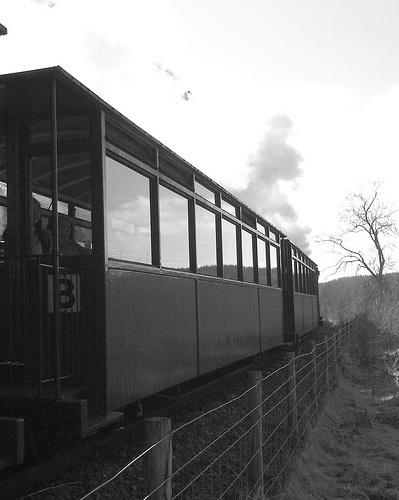What is the person in? The person appears to be inside the train compartment, visible through the window. 